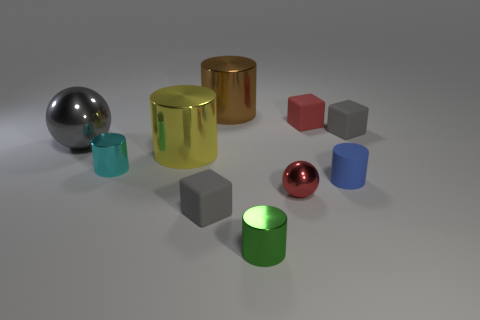Subtract all tiny cylinders. How many cylinders are left? 2 Subtract all blocks. How many objects are left? 7 Subtract 1 balls. How many balls are left? 1 Subtract all green cylinders. Subtract all brown blocks. How many cylinders are left? 4 Subtract all yellow blocks. How many cyan cylinders are left? 1 Subtract all cylinders. Subtract all big yellow objects. How many objects are left? 4 Add 8 small red things. How many small red things are left? 10 Add 5 cyan matte cylinders. How many cyan matte cylinders exist? 5 Subtract all red cubes. How many cubes are left? 2 Subtract 0 brown cubes. How many objects are left? 10 